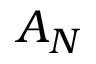Convert formula to latex. <formula><loc_0><loc_0><loc_500><loc_500>A _ { N }</formula> 